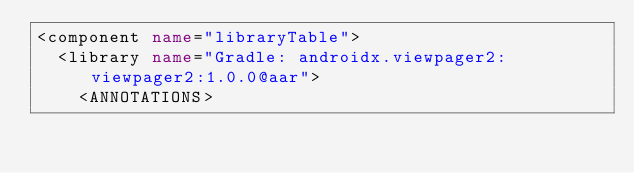Convert code to text. <code><loc_0><loc_0><loc_500><loc_500><_XML_><component name="libraryTable">
  <library name="Gradle: androidx.viewpager2:viewpager2:1.0.0@aar">
    <ANNOTATIONS></code> 